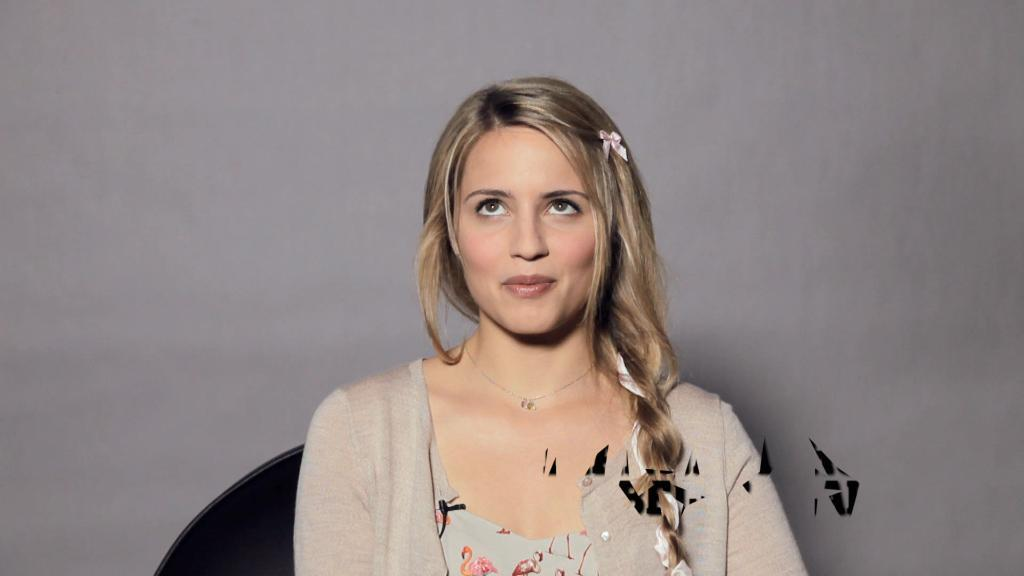Who is the main subject in the image? There is a woman in the center of the image. What can be seen behind the woman? There is a wall in the background of the image. What type of pear is being used as a hat by the woman in the image? There is no pear present in the image, nor is the woman wearing a hat made of a pear. 